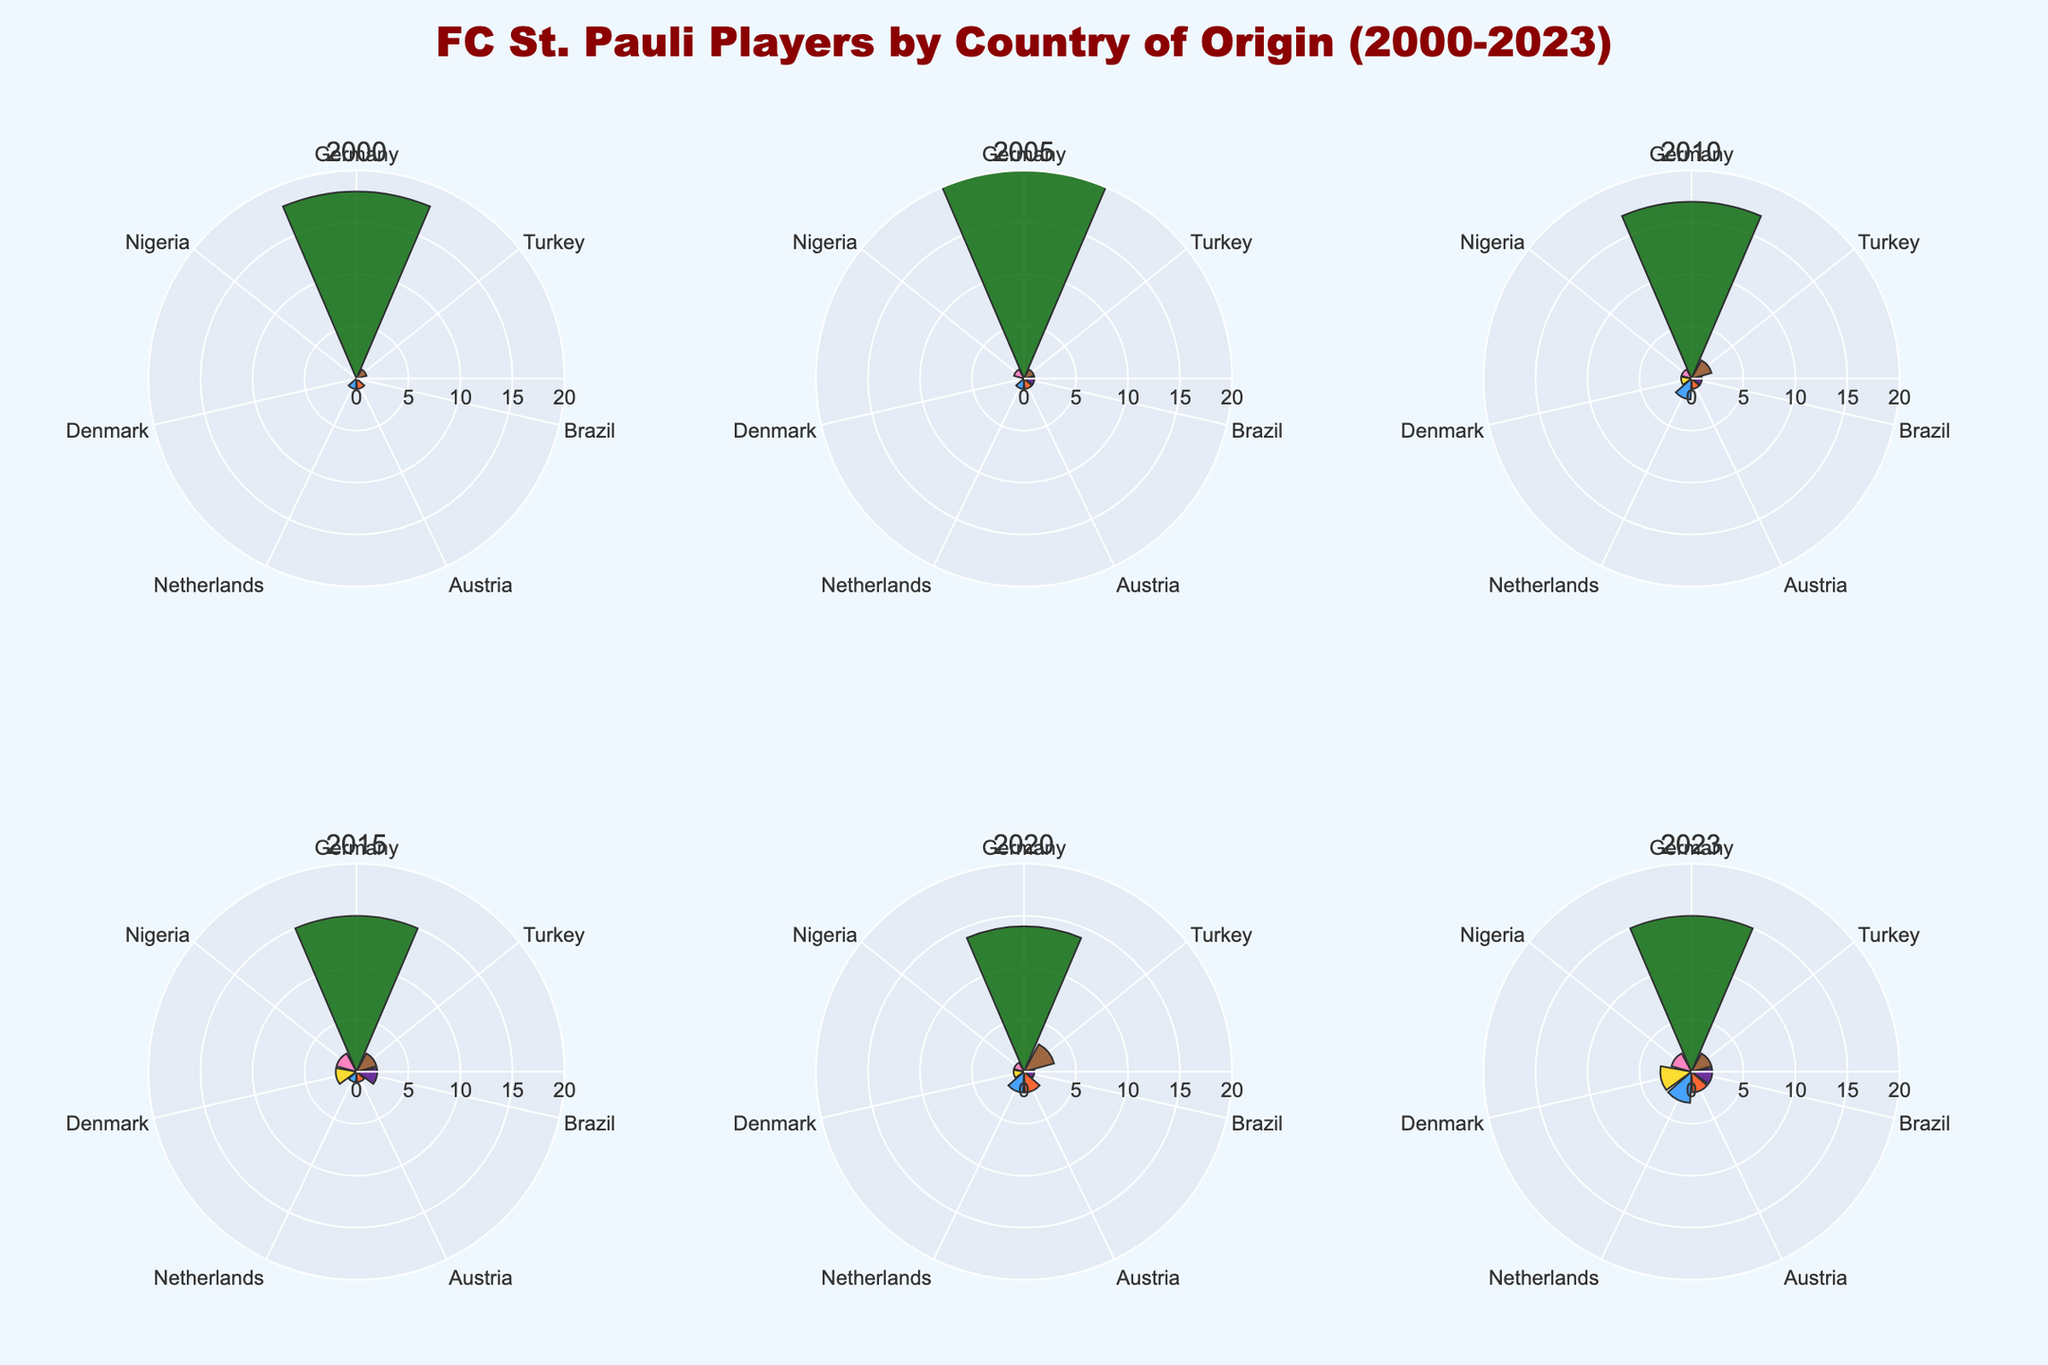what is the title of the figure? The title is usually located at the top of the figure and gives an overview of what the plot represents. By reading it, we can determine the main subject of the figure.
Answer: "FC St. Pauli Players by Country of Origin (2000-2023)" How many players from Germany were part of FC St. Pauli in the year 2023? Locate the polar bar chart for the year 2023 and look for the bar corresponding to Germany. The value on the bar represents the number of players.
Answer: 15 Which country had the highest number of players in 2005? Look at the polar bar chart for the year 2005 and compare the bars for each country. The tallest bar indicates the country with the highest number of players.
Answer: Germany Has the number of players from Nigeria increased or decreased from 2010 to 2023? Compare the bars for Nigeria in the years 2010 and 2023. Check the values to determine if there has been an increase or decrease in the number of players.
Answer: Increased In what year did Austria first have more than one player in FC St. Pauli? Examine the polar bar charts for each year and identify when the bar for Austria exceeds one player for the first time.
Answer: 2020 How many total players were there in 2015 across all countries? Sum the values of the bars in the polar bar chart for 2015 to get the total number of players. Germany (15) + Turkey (2) + Brazil (2) + Austria (1) + Netherlands (1) + Denmark (2) + Nigeria (2) = 25
Answer: 25 Which country showed a consistent increase in the number of players from 2000 to 2023? Examine the trends for each country across all years. Identify the country whose bar heights consistently increase over the years.
Answer: Denmark In 2010, which countries had the same number of players in FC St. Pauli? Compare the bar heights for each country in the polar bar chart for 2010. Identify the countries with equal heights.
Answer: Brazil, Austria, Nigeria (all had 1 player each) What is the average number of players from the Netherlands over the years provided? Sum the number of players from the Netherlands for each year and divide by the number of years to get the average. (1+1+2+1+2+3)/6 = 10/6 = 1.67
Answer: 1.67 Has Brazil ever had zero players in any of the years shown? Check each of the polar bar charts for Brazil to see if there is a bar with a value of zero in any of the years.
Answer: Yes, in 2000 